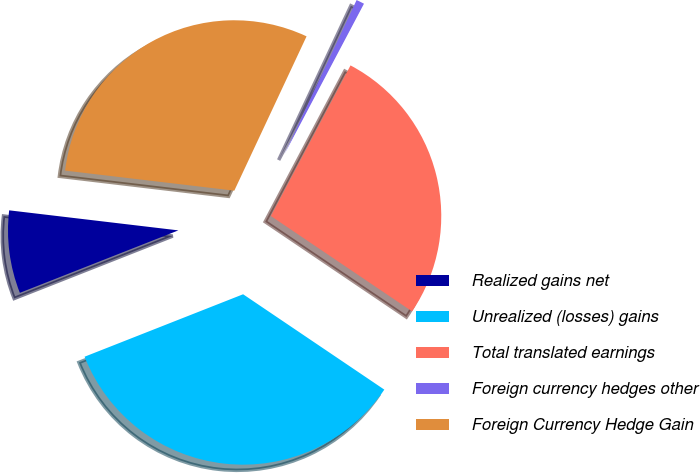Convert chart to OTSL. <chart><loc_0><loc_0><loc_500><loc_500><pie_chart><fcel>Realized gains net<fcel>Unrealized (losses) gains<fcel>Total translated earnings<fcel>Foreign currency hedges other<fcel>Foreign Currency Hedge Gain<nl><fcel>7.85%<fcel>34.57%<fcel>26.71%<fcel>0.77%<fcel>30.09%<nl></chart> 